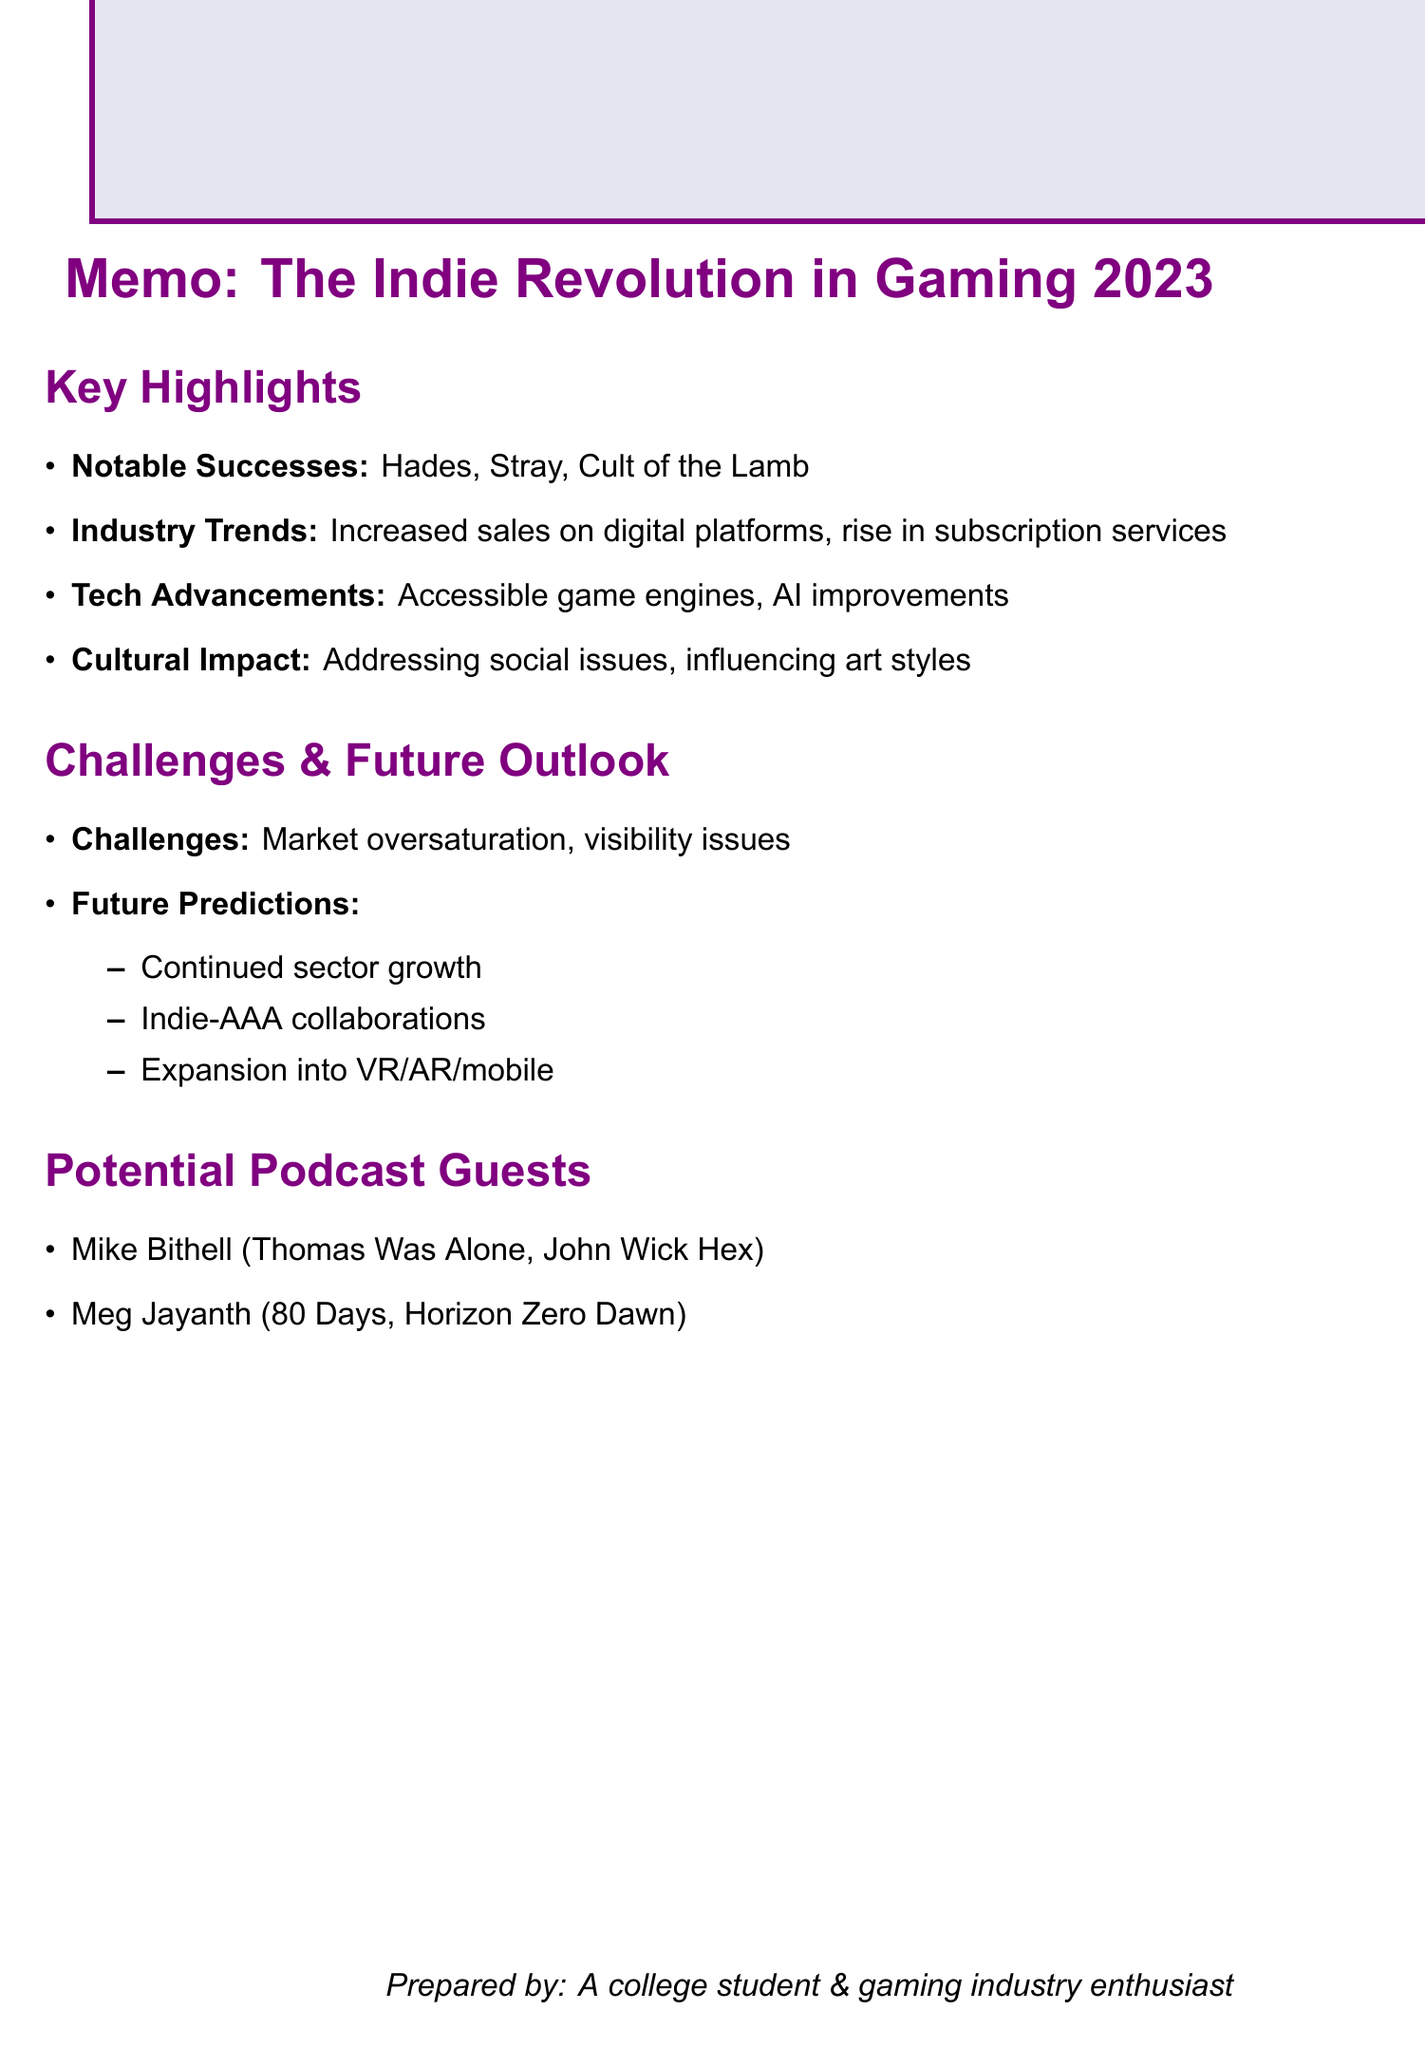What is the title of the podcast episode? The title of the podcast episode is mentioned in the document as “The Indie Revolution: Gaming's Landscape in 2023.”
Answer: The Indie Revolution: Gaming's Landscape in 2023 Who developed the game "Hades"? The developer of the game "Hades" is specified in the document.
Answer: Supergiant Games What has been a notable trend regarding indie games on Steam? The document states there has been an increase in indie game sales on Steam.
Answer: Increase in indie game sales What is one of the challenges faced by indie developers? The document lists multiple challenges, one of which is noted in the section on challenges faced by indie developers.
Answer: Oversaturation of the market What is a predicted future trend for the indie sector? The document provides insights into future predictions, including one regarding collaboration with AAA studios.
Answer: More collaborations between indie and AAA studios Who is a potential podcast guest mentioned in the memo? The memo includes the names of potential guests, prompting for specific examples.
Answer: Mike Bithell What is a major cultural impact of indie games discussed in the document? The document outlines various impacts, including one related to social issues, which illustrates indie games' role in addressing this topic.
Answer: Addressing social issues What type of document is this? The structure and content of the memo indicate its purpose within a specific context related to gaming.
Answer: Memo 